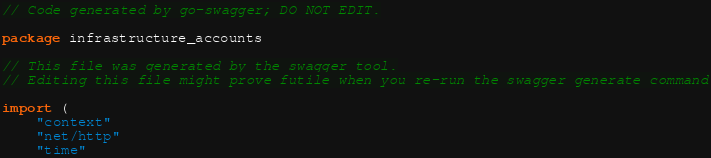<code> <loc_0><loc_0><loc_500><loc_500><_Go_>// Code generated by go-swagger; DO NOT EDIT.

package infrastructure_accounts

// This file was generated by the swagger tool.
// Editing this file might prove futile when you re-run the swagger generate command

import (
	"context"
	"net/http"
	"time"
</code> 